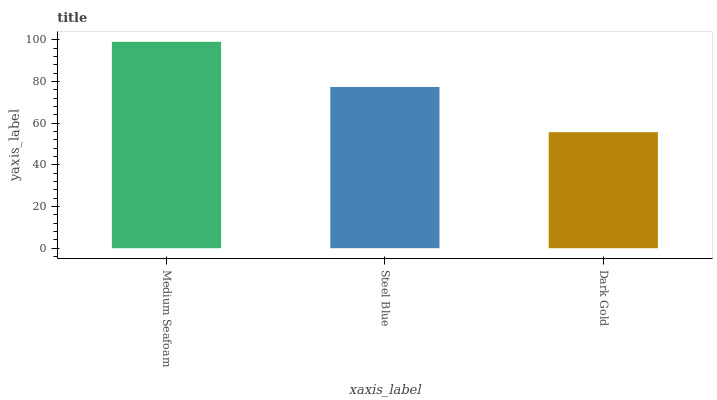Is Dark Gold the minimum?
Answer yes or no. Yes. Is Medium Seafoam the maximum?
Answer yes or no. Yes. Is Steel Blue the minimum?
Answer yes or no. No. Is Steel Blue the maximum?
Answer yes or no. No. Is Medium Seafoam greater than Steel Blue?
Answer yes or no. Yes. Is Steel Blue less than Medium Seafoam?
Answer yes or no. Yes. Is Steel Blue greater than Medium Seafoam?
Answer yes or no. No. Is Medium Seafoam less than Steel Blue?
Answer yes or no. No. Is Steel Blue the high median?
Answer yes or no. Yes. Is Steel Blue the low median?
Answer yes or no. Yes. Is Medium Seafoam the high median?
Answer yes or no. No. Is Dark Gold the low median?
Answer yes or no. No. 